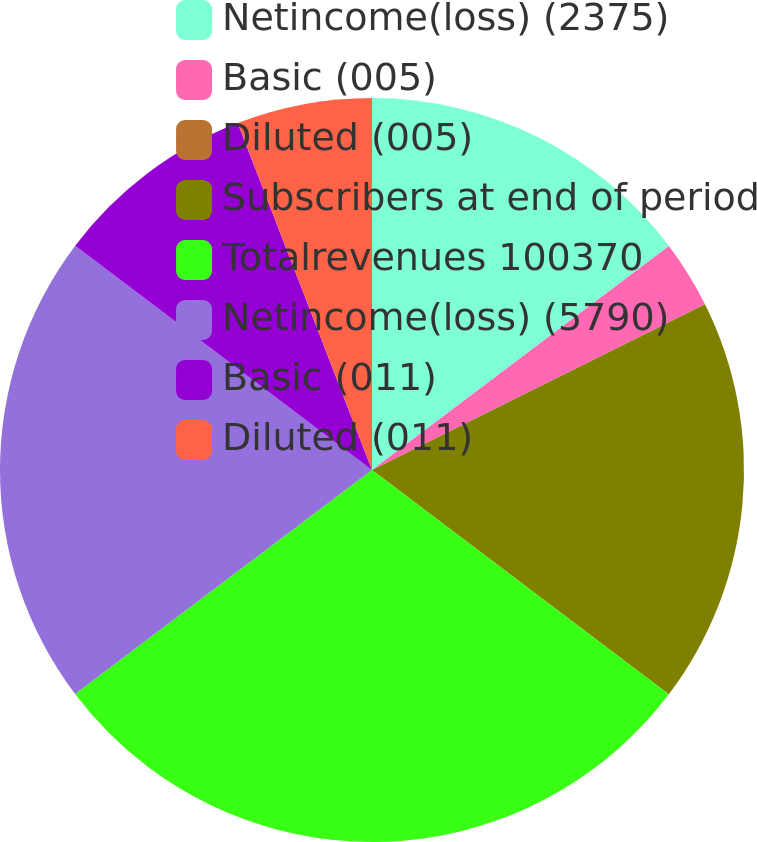Convert chart. <chart><loc_0><loc_0><loc_500><loc_500><pie_chart><fcel>Netincome(loss) (2375)<fcel>Basic (005)<fcel>Diluted (005)<fcel>Subscribers at end of period<fcel>Totalrevenues 100370<fcel>Netincome(loss) (5790)<fcel>Basic (011)<fcel>Diluted (011)<nl><fcel>14.71%<fcel>2.94%<fcel>0.0%<fcel>17.65%<fcel>29.41%<fcel>20.59%<fcel>8.82%<fcel>5.88%<nl></chart> 